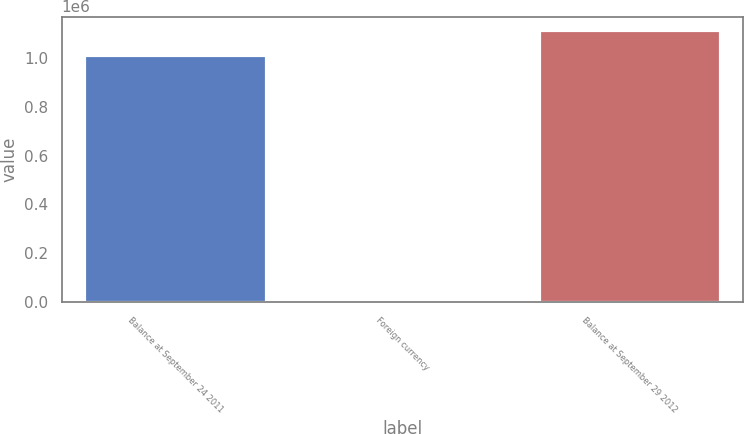<chart> <loc_0><loc_0><loc_500><loc_500><bar_chart><fcel>Balance at September 24 2011<fcel>Foreign currency<fcel>Balance at September 29 2012<nl><fcel>1.00997e+06<fcel>325<fcel>1.11149e+06<nl></chart> 